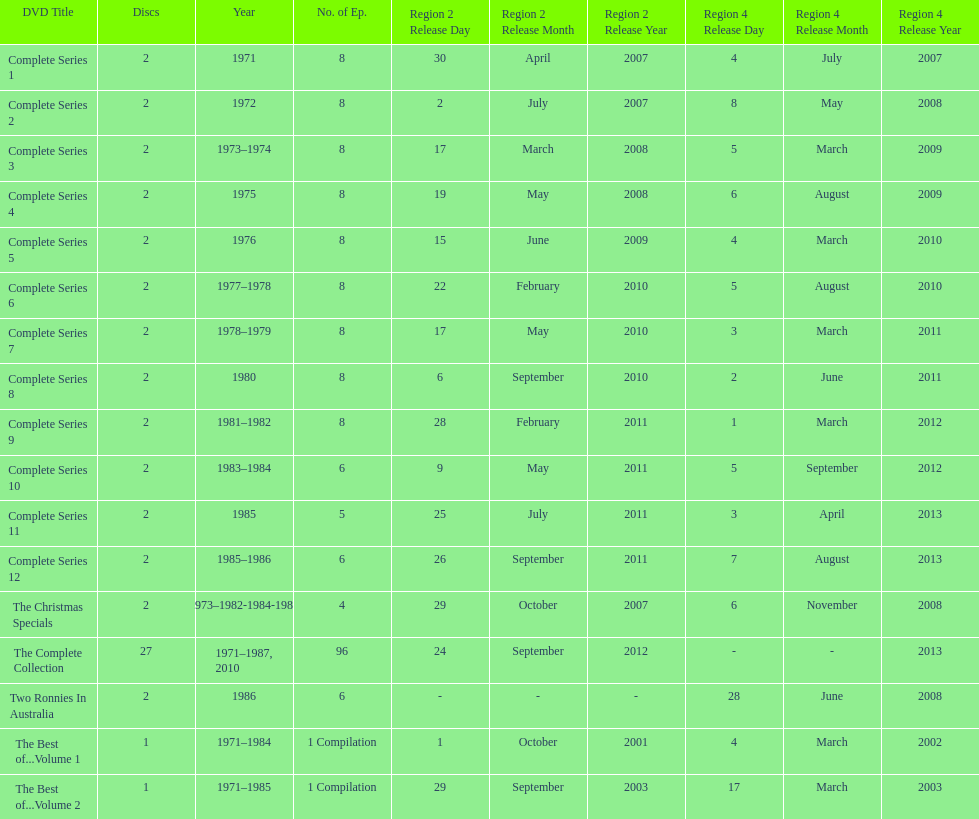How many series had 8 episodes? 9. 